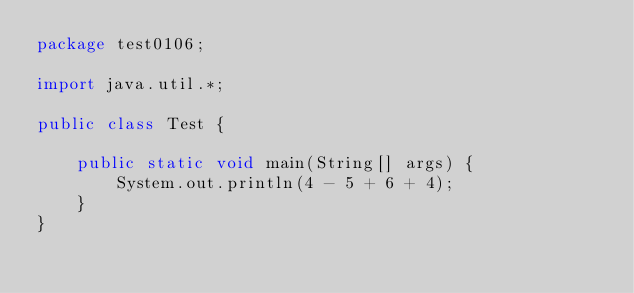<code> <loc_0><loc_0><loc_500><loc_500><_Java_>package test0106;

import java.util.*;

public class Test {

    public static void main(String[] args) {
        System.out.println(4 - 5 + 6 + 4);
    }
}
</code> 